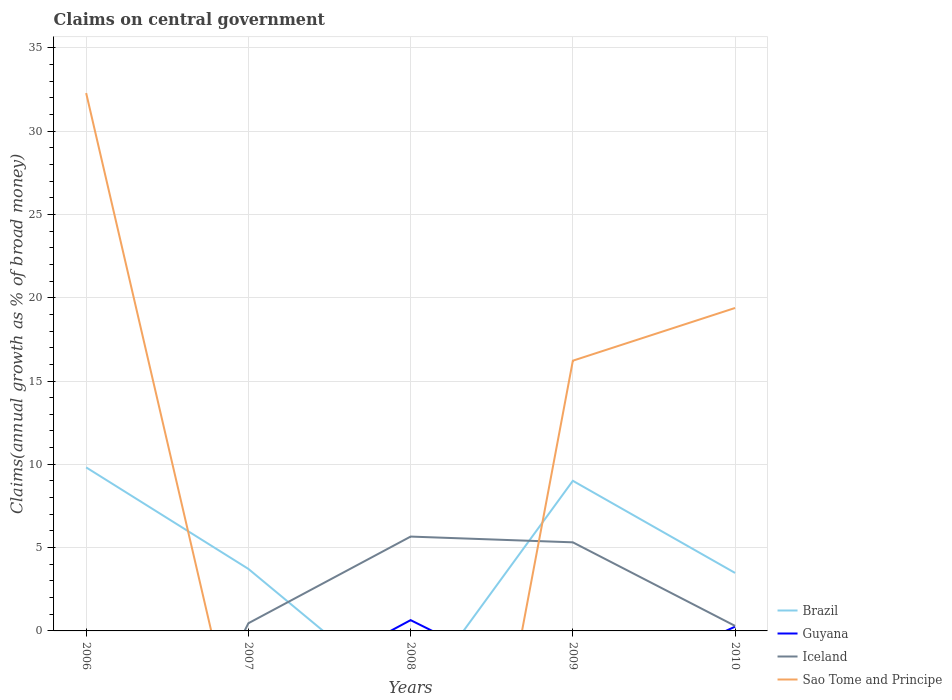How many different coloured lines are there?
Ensure brevity in your answer.  4. Is the number of lines equal to the number of legend labels?
Provide a succinct answer. No. Across all years, what is the maximum percentage of broad money claimed on centeral government in Guyana?
Your answer should be compact. 0. What is the total percentage of broad money claimed on centeral government in Iceland in the graph?
Your answer should be compact. -5.2. What is the difference between the highest and the second highest percentage of broad money claimed on centeral government in Brazil?
Your answer should be very brief. 9.82. What is the difference between the highest and the lowest percentage of broad money claimed on centeral government in Iceland?
Offer a very short reply. 2. What is the difference between two consecutive major ticks on the Y-axis?
Offer a terse response. 5. How many legend labels are there?
Provide a short and direct response. 4. What is the title of the graph?
Your answer should be compact. Claims on central government. Does "Brunei Darussalam" appear as one of the legend labels in the graph?
Provide a short and direct response. No. What is the label or title of the Y-axis?
Your answer should be compact. Claims(annual growth as % of broad money). What is the Claims(annual growth as % of broad money) of Brazil in 2006?
Give a very brief answer. 9.82. What is the Claims(annual growth as % of broad money) in Guyana in 2006?
Offer a very short reply. 0. What is the Claims(annual growth as % of broad money) in Iceland in 2006?
Offer a very short reply. 0. What is the Claims(annual growth as % of broad money) of Sao Tome and Principe in 2006?
Your response must be concise. 32.28. What is the Claims(annual growth as % of broad money) in Brazil in 2007?
Provide a succinct answer. 3.72. What is the Claims(annual growth as % of broad money) of Guyana in 2007?
Provide a succinct answer. 0. What is the Claims(annual growth as % of broad money) of Iceland in 2007?
Your answer should be very brief. 0.46. What is the Claims(annual growth as % of broad money) of Sao Tome and Principe in 2007?
Offer a terse response. 0. What is the Claims(annual growth as % of broad money) in Guyana in 2008?
Give a very brief answer. 0.65. What is the Claims(annual growth as % of broad money) in Iceland in 2008?
Offer a terse response. 5.66. What is the Claims(annual growth as % of broad money) of Brazil in 2009?
Keep it short and to the point. 9.01. What is the Claims(annual growth as % of broad money) in Iceland in 2009?
Make the answer very short. 5.32. What is the Claims(annual growth as % of broad money) in Sao Tome and Principe in 2009?
Your answer should be compact. 16.22. What is the Claims(annual growth as % of broad money) in Brazil in 2010?
Make the answer very short. 3.48. What is the Claims(annual growth as % of broad money) of Guyana in 2010?
Offer a very short reply. 0.25. What is the Claims(annual growth as % of broad money) of Iceland in 2010?
Ensure brevity in your answer.  0.3. What is the Claims(annual growth as % of broad money) of Sao Tome and Principe in 2010?
Your response must be concise. 19.38. Across all years, what is the maximum Claims(annual growth as % of broad money) in Brazil?
Provide a succinct answer. 9.82. Across all years, what is the maximum Claims(annual growth as % of broad money) in Guyana?
Your response must be concise. 0.65. Across all years, what is the maximum Claims(annual growth as % of broad money) of Iceland?
Offer a very short reply. 5.66. Across all years, what is the maximum Claims(annual growth as % of broad money) of Sao Tome and Principe?
Your answer should be very brief. 32.28. Across all years, what is the minimum Claims(annual growth as % of broad money) in Brazil?
Keep it short and to the point. 0. Across all years, what is the minimum Claims(annual growth as % of broad money) in Iceland?
Your answer should be compact. 0. What is the total Claims(annual growth as % of broad money) of Brazil in the graph?
Your response must be concise. 26.03. What is the total Claims(annual growth as % of broad money) in Guyana in the graph?
Offer a terse response. 0.9. What is the total Claims(annual growth as % of broad money) of Iceland in the graph?
Your response must be concise. 11.74. What is the total Claims(annual growth as % of broad money) in Sao Tome and Principe in the graph?
Offer a very short reply. 67.89. What is the difference between the Claims(annual growth as % of broad money) in Brazil in 2006 and that in 2007?
Your answer should be compact. 6.09. What is the difference between the Claims(annual growth as % of broad money) of Brazil in 2006 and that in 2009?
Give a very brief answer. 0.8. What is the difference between the Claims(annual growth as % of broad money) in Sao Tome and Principe in 2006 and that in 2009?
Keep it short and to the point. 16.06. What is the difference between the Claims(annual growth as % of broad money) in Brazil in 2006 and that in 2010?
Make the answer very short. 6.33. What is the difference between the Claims(annual growth as % of broad money) of Sao Tome and Principe in 2006 and that in 2010?
Keep it short and to the point. 12.9. What is the difference between the Claims(annual growth as % of broad money) of Iceland in 2007 and that in 2008?
Provide a succinct answer. -5.2. What is the difference between the Claims(annual growth as % of broad money) in Brazil in 2007 and that in 2009?
Offer a terse response. -5.29. What is the difference between the Claims(annual growth as % of broad money) of Iceland in 2007 and that in 2009?
Provide a succinct answer. -4.86. What is the difference between the Claims(annual growth as % of broad money) in Brazil in 2007 and that in 2010?
Ensure brevity in your answer.  0.24. What is the difference between the Claims(annual growth as % of broad money) of Iceland in 2007 and that in 2010?
Keep it short and to the point. 0.16. What is the difference between the Claims(annual growth as % of broad money) in Iceland in 2008 and that in 2009?
Ensure brevity in your answer.  0.35. What is the difference between the Claims(annual growth as % of broad money) of Guyana in 2008 and that in 2010?
Offer a very short reply. 0.39. What is the difference between the Claims(annual growth as % of broad money) of Iceland in 2008 and that in 2010?
Give a very brief answer. 5.36. What is the difference between the Claims(annual growth as % of broad money) of Brazil in 2009 and that in 2010?
Provide a succinct answer. 5.53. What is the difference between the Claims(annual growth as % of broad money) of Iceland in 2009 and that in 2010?
Make the answer very short. 5.02. What is the difference between the Claims(annual growth as % of broad money) in Sao Tome and Principe in 2009 and that in 2010?
Make the answer very short. -3.16. What is the difference between the Claims(annual growth as % of broad money) in Brazil in 2006 and the Claims(annual growth as % of broad money) in Iceland in 2007?
Ensure brevity in your answer.  9.35. What is the difference between the Claims(annual growth as % of broad money) of Brazil in 2006 and the Claims(annual growth as % of broad money) of Guyana in 2008?
Ensure brevity in your answer.  9.17. What is the difference between the Claims(annual growth as % of broad money) of Brazil in 2006 and the Claims(annual growth as % of broad money) of Iceland in 2008?
Provide a succinct answer. 4.15. What is the difference between the Claims(annual growth as % of broad money) in Brazil in 2006 and the Claims(annual growth as % of broad money) in Iceland in 2009?
Offer a terse response. 4.5. What is the difference between the Claims(annual growth as % of broad money) of Brazil in 2006 and the Claims(annual growth as % of broad money) of Sao Tome and Principe in 2009?
Your answer should be compact. -6.4. What is the difference between the Claims(annual growth as % of broad money) in Brazil in 2006 and the Claims(annual growth as % of broad money) in Guyana in 2010?
Ensure brevity in your answer.  9.56. What is the difference between the Claims(annual growth as % of broad money) of Brazil in 2006 and the Claims(annual growth as % of broad money) of Iceland in 2010?
Your answer should be compact. 9.51. What is the difference between the Claims(annual growth as % of broad money) of Brazil in 2006 and the Claims(annual growth as % of broad money) of Sao Tome and Principe in 2010?
Ensure brevity in your answer.  -9.57. What is the difference between the Claims(annual growth as % of broad money) in Brazil in 2007 and the Claims(annual growth as % of broad money) in Guyana in 2008?
Ensure brevity in your answer.  3.07. What is the difference between the Claims(annual growth as % of broad money) in Brazil in 2007 and the Claims(annual growth as % of broad money) in Iceland in 2008?
Keep it short and to the point. -1.94. What is the difference between the Claims(annual growth as % of broad money) of Brazil in 2007 and the Claims(annual growth as % of broad money) of Iceland in 2009?
Offer a very short reply. -1.6. What is the difference between the Claims(annual growth as % of broad money) in Brazil in 2007 and the Claims(annual growth as % of broad money) in Sao Tome and Principe in 2009?
Ensure brevity in your answer.  -12.5. What is the difference between the Claims(annual growth as % of broad money) of Iceland in 2007 and the Claims(annual growth as % of broad money) of Sao Tome and Principe in 2009?
Your answer should be compact. -15.76. What is the difference between the Claims(annual growth as % of broad money) of Brazil in 2007 and the Claims(annual growth as % of broad money) of Guyana in 2010?
Your response must be concise. 3.47. What is the difference between the Claims(annual growth as % of broad money) in Brazil in 2007 and the Claims(annual growth as % of broad money) in Iceland in 2010?
Provide a succinct answer. 3.42. What is the difference between the Claims(annual growth as % of broad money) of Brazil in 2007 and the Claims(annual growth as % of broad money) of Sao Tome and Principe in 2010?
Offer a very short reply. -15.66. What is the difference between the Claims(annual growth as % of broad money) of Iceland in 2007 and the Claims(annual growth as % of broad money) of Sao Tome and Principe in 2010?
Your response must be concise. -18.92. What is the difference between the Claims(annual growth as % of broad money) in Guyana in 2008 and the Claims(annual growth as % of broad money) in Iceland in 2009?
Give a very brief answer. -4.67. What is the difference between the Claims(annual growth as % of broad money) in Guyana in 2008 and the Claims(annual growth as % of broad money) in Sao Tome and Principe in 2009?
Provide a succinct answer. -15.57. What is the difference between the Claims(annual growth as % of broad money) in Iceland in 2008 and the Claims(annual growth as % of broad money) in Sao Tome and Principe in 2009?
Provide a succinct answer. -10.56. What is the difference between the Claims(annual growth as % of broad money) in Guyana in 2008 and the Claims(annual growth as % of broad money) in Iceland in 2010?
Offer a terse response. 0.35. What is the difference between the Claims(annual growth as % of broad money) of Guyana in 2008 and the Claims(annual growth as % of broad money) of Sao Tome and Principe in 2010?
Offer a very short reply. -18.74. What is the difference between the Claims(annual growth as % of broad money) of Iceland in 2008 and the Claims(annual growth as % of broad money) of Sao Tome and Principe in 2010?
Provide a succinct answer. -13.72. What is the difference between the Claims(annual growth as % of broad money) in Brazil in 2009 and the Claims(annual growth as % of broad money) in Guyana in 2010?
Provide a short and direct response. 8.76. What is the difference between the Claims(annual growth as % of broad money) in Brazil in 2009 and the Claims(annual growth as % of broad money) in Iceland in 2010?
Give a very brief answer. 8.71. What is the difference between the Claims(annual growth as % of broad money) in Brazil in 2009 and the Claims(annual growth as % of broad money) in Sao Tome and Principe in 2010?
Your answer should be compact. -10.37. What is the difference between the Claims(annual growth as % of broad money) of Iceland in 2009 and the Claims(annual growth as % of broad money) of Sao Tome and Principe in 2010?
Ensure brevity in your answer.  -14.07. What is the average Claims(annual growth as % of broad money) in Brazil per year?
Ensure brevity in your answer.  5.21. What is the average Claims(annual growth as % of broad money) of Guyana per year?
Provide a short and direct response. 0.18. What is the average Claims(annual growth as % of broad money) of Iceland per year?
Offer a terse response. 2.35. What is the average Claims(annual growth as % of broad money) in Sao Tome and Principe per year?
Your answer should be very brief. 13.58. In the year 2006, what is the difference between the Claims(annual growth as % of broad money) of Brazil and Claims(annual growth as % of broad money) of Sao Tome and Principe?
Provide a short and direct response. -22.47. In the year 2007, what is the difference between the Claims(annual growth as % of broad money) of Brazil and Claims(annual growth as % of broad money) of Iceland?
Ensure brevity in your answer.  3.26. In the year 2008, what is the difference between the Claims(annual growth as % of broad money) of Guyana and Claims(annual growth as % of broad money) of Iceland?
Keep it short and to the point. -5.02. In the year 2009, what is the difference between the Claims(annual growth as % of broad money) of Brazil and Claims(annual growth as % of broad money) of Iceland?
Provide a succinct answer. 3.69. In the year 2009, what is the difference between the Claims(annual growth as % of broad money) of Brazil and Claims(annual growth as % of broad money) of Sao Tome and Principe?
Offer a very short reply. -7.21. In the year 2009, what is the difference between the Claims(annual growth as % of broad money) of Iceland and Claims(annual growth as % of broad money) of Sao Tome and Principe?
Offer a very short reply. -10.9. In the year 2010, what is the difference between the Claims(annual growth as % of broad money) of Brazil and Claims(annual growth as % of broad money) of Guyana?
Provide a succinct answer. 3.23. In the year 2010, what is the difference between the Claims(annual growth as % of broad money) of Brazil and Claims(annual growth as % of broad money) of Iceland?
Offer a very short reply. 3.18. In the year 2010, what is the difference between the Claims(annual growth as % of broad money) of Brazil and Claims(annual growth as % of broad money) of Sao Tome and Principe?
Give a very brief answer. -15.9. In the year 2010, what is the difference between the Claims(annual growth as % of broad money) in Guyana and Claims(annual growth as % of broad money) in Iceland?
Give a very brief answer. -0.05. In the year 2010, what is the difference between the Claims(annual growth as % of broad money) of Guyana and Claims(annual growth as % of broad money) of Sao Tome and Principe?
Offer a terse response. -19.13. In the year 2010, what is the difference between the Claims(annual growth as % of broad money) in Iceland and Claims(annual growth as % of broad money) in Sao Tome and Principe?
Your answer should be very brief. -19.08. What is the ratio of the Claims(annual growth as % of broad money) in Brazil in 2006 to that in 2007?
Your answer should be very brief. 2.64. What is the ratio of the Claims(annual growth as % of broad money) in Brazil in 2006 to that in 2009?
Your response must be concise. 1.09. What is the ratio of the Claims(annual growth as % of broad money) in Sao Tome and Principe in 2006 to that in 2009?
Offer a very short reply. 1.99. What is the ratio of the Claims(annual growth as % of broad money) of Brazil in 2006 to that in 2010?
Your response must be concise. 2.82. What is the ratio of the Claims(annual growth as % of broad money) in Sao Tome and Principe in 2006 to that in 2010?
Provide a short and direct response. 1.67. What is the ratio of the Claims(annual growth as % of broad money) of Iceland in 2007 to that in 2008?
Offer a terse response. 0.08. What is the ratio of the Claims(annual growth as % of broad money) in Brazil in 2007 to that in 2009?
Make the answer very short. 0.41. What is the ratio of the Claims(annual growth as % of broad money) of Iceland in 2007 to that in 2009?
Offer a very short reply. 0.09. What is the ratio of the Claims(annual growth as % of broad money) of Brazil in 2007 to that in 2010?
Provide a succinct answer. 1.07. What is the ratio of the Claims(annual growth as % of broad money) in Iceland in 2007 to that in 2010?
Offer a very short reply. 1.53. What is the ratio of the Claims(annual growth as % of broad money) of Iceland in 2008 to that in 2009?
Give a very brief answer. 1.06. What is the ratio of the Claims(annual growth as % of broad money) of Guyana in 2008 to that in 2010?
Your answer should be very brief. 2.54. What is the ratio of the Claims(annual growth as % of broad money) in Iceland in 2008 to that in 2010?
Your response must be concise. 18.84. What is the ratio of the Claims(annual growth as % of broad money) in Brazil in 2009 to that in 2010?
Offer a very short reply. 2.59. What is the ratio of the Claims(annual growth as % of broad money) of Iceland in 2009 to that in 2010?
Your answer should be very brief. 17.69. What is the ratio of the Claims(annual growth as % of broad money) in Sao Tome and Principe in 2009 to that in 2010?
Your answer should be compact. 0.84. What is the difference between the highest and the second highest Claims(annual growth as % of broad money) in Brazil?
Make the answer very short. 0.8. What is the difference between the highest and the second highest Claims(annual growth as % of broad money) of Iceland?
Keep it short and to the point. 0.35. What is the difference between the highest and the second highest Claims(annual growth as % of broad money) of Sao Tome and Principe?
Your answer should be very brief. 12.9. What is the difference between the highest and the lowest Claims(annual growth as % of broad money) in Brazil?
Keep it short and to the point. 9.82. What is the difference between the highest and the lowest Claims(annual growth as % of broad money) of Guyana?
Ensure brevity in your answer.  0.65. What is the difference between the highest and the lowest Claims(annual growth as % of broad money) of Iceland?
Provide a short and direct response. 5.66. What is the difference between the highest and the lowest Claims(annual growth as % of broad money) of Sao Tome and Principe?
Ensure brevity in your answer.  32.28. 